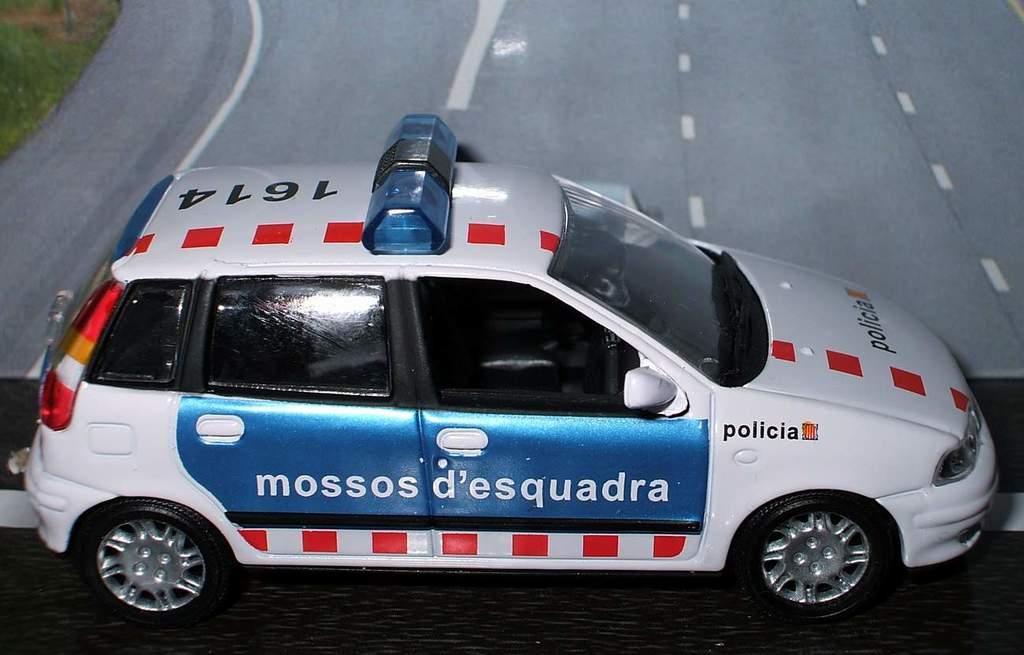Can you describe this image briefly? This picture shows a toy police car and we see picture of a road on the background. 